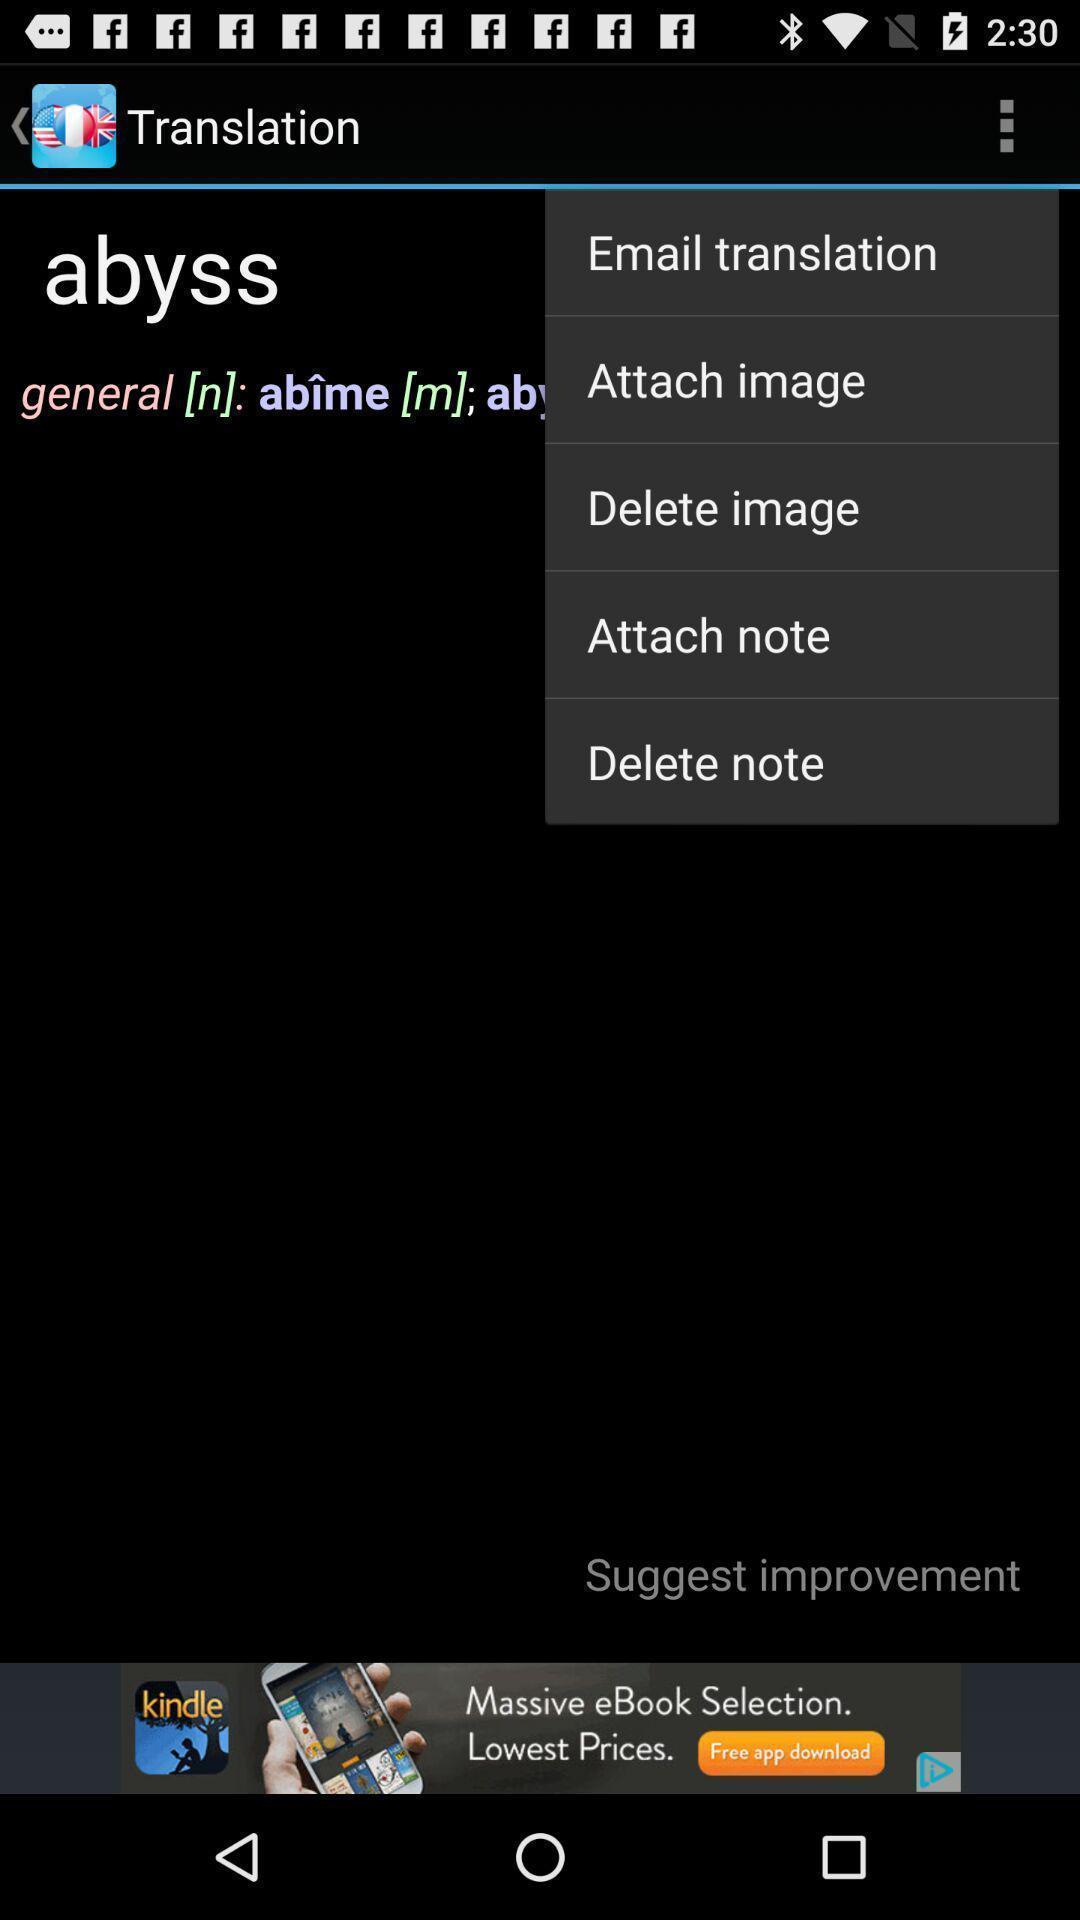Provide a detailed account of this screenshot. Screen displaying multiple options in a dictionary application. 